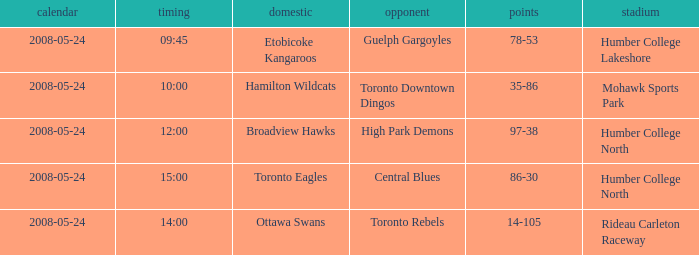On what grounds did the away team of the Toronto Rebels play? Rideau Carleton Raceway. 